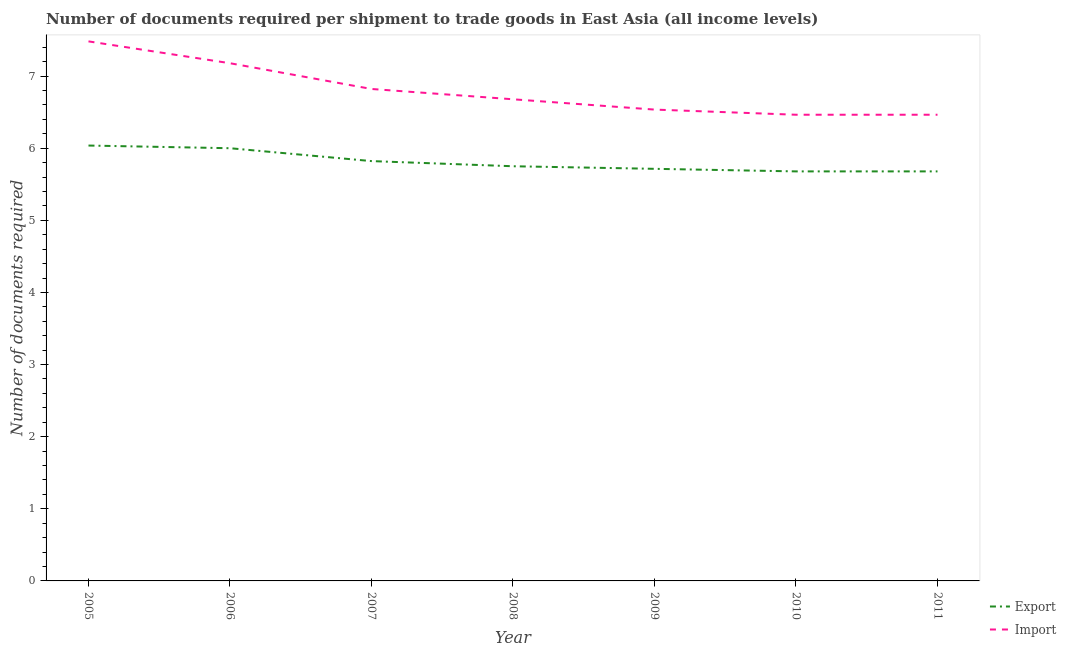How many different coloured lines are there?
Offer a terse response. 2. Does the line corresponding to number of documents required to import goods intersect with the line corresponding to number of documents required to export goods?
Offer a terse response. No. Is the number of lines equal to the number of legend labels?
Give a very brief answer. Yes. What is the number of documents required to export goods in 2011?
Ensure brevity in your answer.  5.68. Across all years, what is the maximum number of documents required to export goods?
Keep it short and to the point. 6.04. Across all years, what is the minimum number of documents required to export goods?
Your answer should be compact. 5.68. In which year was the number of documents required to import goods minimum?
Keep it short and to the point. 2010. What is the total number of documents required to export goods in the graph?
Offer a very short reply. 40.68. What is the difference between the number of documents required to import goods in 2009 and that in 2010?
Provide a short and direct response. 0.07. What is the difference between the number of documents required to import goods in 2010 and the number of documents required to export goods in 2009?
Offer a terse response. 0.75. What is the average number of documents required to import goods per year?
Give a very brief answer. 6.8. In the year 2007, what is the difference between the number of documents required to import goods and number of documents required to export goods?
Ensure brevity in your answer.  1. In how many years, is the number of documents required to export goods greater than 1?
Offer a very short reply. 7. What is the ratio of the number of documents required to import goods in 2007 to that in 2011?
Your answer should be very brief. 1.06. Is the number of documents required to export goods in 2005 less than that in 2011?
Ensure brevity in your answer.  No. Is the difference between the number of documents required to export goods in 2008 and 2010 greater than the difference between the number of documents required to import goods in 2008 and 2010?
Ensure brevity in your answer.  No. What is the difference between the highest and the second highest number of documents required to import goods?
Keep it short and to the point. 0.3. What is the difference between the highest and the lowest number of documents required to import goods?
Provide a short and direct response. 1.02. Is the sum of the number of documents required to import goods in 2006 and 2009 greater than the maximum number of documents required to export goods across all years?
Offer a terse response. Yes. Is the number of documents required to import goods strictly greater than the number of documents required to export goods over the years?
Your response must be concise. Yes. How many lines are there?
Your answer should be compact. 2. What is the difference between two consecutive major ticks on the Y-axis?
Your response must be concise. 1. Are the values on the major ticks of Y-axis written in scientific E-notation?
Your answer should be very brief. No. Does the graph contain any zero values?
Your answer should be compact. No. How many legend labels are there?
Offer a terse response. 2. How are the legend labels stacked?
Offer a terse response. Vertical. What is the title of the graph?
Offer a very short reply. Number of documents required per shipment to trade goods in East Asia (all income levels). Does "Constant 2005 US$" appear as one of the legend labels in the graph?
Provide a short and direct response. No. What is the label or title of the Y-axis?
Keep it short and to the point. Number of documents required. What is the Number of documents required of Export in 2005?
Keep it short and to the point. 6.04. What is the Number of documents required in Import in 2005?
Give a very brief answer. 7.48. What is the Number of documents required of Import in 2006?
Offer a terse response. 7.18. What is the Number of documents required in Export in 2007?
Your answer should be compact. 5.82. What is the Number of documents required of Import in 2007?
Keep it short and to the point. 6.82. What is the Number of documents required of Export in 2008?
Your answer should be compact. 5.75. What is the Number of documents required in Import in 2008?
Ensure brevity in your answer.  6.68. What is the Number of documents required of Export in 2009?
Your answer should be compact. 5.71. What is the Number of documents required of Import in 2009?
Your answer should be very brief. 6.54. What is the Number of documents required in Export in 2010?
Provide a short and direct response. 5.68. What is the Number of documents required in Import in 2010?
Your answer should be compact. 6.46. What is the Number of documents required in Export in 2011?
Your answer should be compact. 5.68. What is the Number of documents required of Import in 2011?
Offer a terse response. 6.46. Across all years, what is the maximum Number of documents required of Export?
Provide a succinct answer. 6.04. Across all years, what is the maximum Number of documents required in Import?
Offer a very short reply. 7.48. Across all years, what is the minimum Number of documents required of Export?
Your response must be concise. 5.68. Across all years, what is the minimum Number of documents required of Import?
Offer a terse response. 6.46. What is the total Number of documents required in Export in the graph?
Give a very brief answer. 40.68. What is the total Number of documents required in Import in the graph?
Ensure brevity in your answer.  47.62. What is the difference between the Number of documents required of Export in 2005 and that in 2006?
Ensure brevity in your answer.  0.04. What is the difference between the Number of documents required of Import in 2005 and that in 2006?
Provide a succinct answer. 0.3. What is the difference between the Number of documents required in Export in 2005 and that in 2007?
Give a very brief answer. 0.22. What is the difference between the Number of documents required in Import in 2005 and that in 2007?
Your answer should be compact. 0.66. What is the difference between the Number of documents required of Export in 2005 and that in 2008?
Offer a terse response. 0.29. What is the difference between the Number of documents required of Import in 2005 and that in 2008?
Your answer should be very brief. 0.8. What is the difference between the Number of documents required of Export in 2005 and that in 2009?
Provide a succinct answer. 0.32. What is the difference between the Number of documents required of Import in 2005 and that in 2009?
Offer a terse response. 0.95. What is the difference between the Number of documents required of Export in 2005 and that in 2010?
Provide a succinct answer. 0.36. What is the difference between the Number of documents required of Import in 2005 and that in 2010?
Offer a terse response. 1.02. What is the difference between the Number of documents required of Export in 2005 and that in 2011?
Keep it short and to the point. 0.36. What is the difference between the Number of documents required in Import in 2005 and that in 2011?
Your answer should be compact. 1.02. What is the difference between the Number of documents required in Export in 2006 and that in 2007?
Your answer should be very brief. 0.18. What is the difference between the Number of documents required of Import in 2006 and that in 2007?
Your answer should be very brief. 0.36. What is the difference between the Number of documents required in Export in 2006 and that in 2008?
Keep it short and to the point. 0.25. What is the difference between the Number of documents required in Import in 2006 and that in 2008?
Your answer should be compact. 0.5. What is the difference between the Number of documents required in Export in 2006 and that in 2009?
Provide a short and direct response. 0.29. What is the difference between the Number of documents required of Import in 2006 and that in 2009?
Offer a terse response. 0.64. What is the difference between the Number of documents required in Export in 2006 and that in 2010?
Offer a very short reply. 0.32. What is the difference between the Number of documents required of Export in 2006 and that in 2011?
Offer a very short reply. 0.32. What is the difference between the Number of documents required in Export in 2007 and that in 2008?
Your answer should be compact. 0.07. What is the difference between the Number of documents required of Import in 2007 and that in 2008?
Keep it short and to the point. 0.14. What is the difference between the Number of documents required of Export in 2007 and that in 2009?
Offer a terse response. 0.11. What is the difference between the Number of documents required in Import in 2007 and that in 2009?
Offer a terse response. 0.29. What is the difference between the Number of documents required in Export in 2007 and that in 2010?
Offer a very short reply. 0.14. What is the difference between the Number of documents required of Import in 2007 and that in 2010?
Give a very brief answer. 0.36. What is the difference between the Number of documents required of Export in 2007 and that in 2011?
Keep it short and to the point. 0.14. What is the difference between the Number of documents required of Import in 2007 and that in 2011?
Your answer should be very brief. 0.36. What is the difference between the Number of documents required of Export in 2008 and that in 2009?
Keep it short and to the point. 0.04. What is the difference between the Number of documents required in Import in 2008 and that in 2009?
Your answer should be very brief. 0.14. What is the difference between the Number of documents required of Export in 2008 and that in 2010?
Your answer should be very brief. 0.07. What is the difference between the Number of documents required of Import in 2008 and that in 2010?
Offer a terse response. 0.21. What is the difference between the Number of documents required in Export in 2008 and that in 2011?
Offer a very short reply. 0.07. What is the difference between the Number of documents required of Import in 2008 and that in 2011?
Ensure brevity in your answer.  0.21. What is the difference between the Number of documents required of Export in 2009 and that in 2010?
Offer a terse response. 0.04. What is the difference between the Number of documents required in Import in 2009 and that in 2010?
Your answer should be compact. 0.07. What is the difference between the Number of documents required in Export in 2009 and that in 2011?
Provide a succinct answer. 0.04. What is the difference between the Number of documents required in Import in 2009 and that in 2011?
Offer a very short reply. 0.07. What is the difference between the Number of documents required in Export in 2010 and that in 2011?
Provide a short and direct response. 0. What is the difference between the Number of documents required in Export in 2005 and the Number of documents required in Import in 2006?
Make the answer very short. -1.14. What is the difference between the Number of documents required of Export in 2005 and the Number of documents required of Import in 2007?
Offer a very short reply. -0.78. What is the difference between the Number of documents required in Export in 2005 and the Number of documents required in Import in 2008?
Provide a short and direct response. -0.64. What is the difference between the Number of documents required in Export in 2005 and the Number of documents required in Import in 2009?
Your response must be concise. -0.5. What is the difference between the Number of documents required in Export in 2005 and the Number of documents required in Import in 2010?
Your answer should be compact. -0.43. What is the difference between the Number of documents required in Export in 2005 and the Number of documents required in Import in 2011?
Your answer should be compact. -0.43. What is the difference between the Number of documents required in Export in 2006 and the Number of documents required in Import in 2007?
Make the answer very short. -0.82. What is the difference between the Number of documents required in Export in 2006 and the Number of documents required in Import in 2008?
Ensure brevity in your answer.  -0.68. What is the difference between the Number of documents required in Export in 2006 and the Number of documents required in Import in 2009?
Offer a very short reply. -0.54. What is the difference between the Number of documents required of Export in 2006 and the Number of documents required of Import in 2010?
Your answer should be very brief. -0.46. What is the difference between the Number of documents required of Export in 2006 and the Number of documents required of Import in 2011?
Give a very brief answer. -0.46. What is the difference between the Number of documents required in Export in 2007 and the Number of documents required in Import in 2008?
Give a very brief answer. -0.86. What is the difference between the Number of documents required of Export in 2007 and the Number of documents required of Import in 2009?
Offer a very short reply. -0.71. What is the difference between the Number of documents required of Export in 2007 and the Number of documents required of Import in 2010?
Ensure brevity in your answer.  -0.64. What is the difference between the Number of documents required of Export in 2007 and the Number of documents required of Import in 2011?
Ensure brevity in your answer.  -0.64. What is the difference between the Number of documents required of Export in 2008 and the Number of documents required of Import in 2009?
Provide a short and direct response. -0.79. What is the difference between the Number of documents required of Export in 2008 and the Number of documents required of Import in 2010?
Give a very brief answer. -0.71. What is the difference between the Number of documents required in Export in 2008 and the Number of documents required in Import in 2011?
Your answer should be compact. -0.71. What is the difference between the Number of documents required of Export in 2009 and the Number of documents required of Import in 2010?
Give a very brief answer. -0.75. What is the difference between the Number of documents required of Export in 2009 and the Number of documents required of Import in 2011?
Provide a short and direct response. -0.75. What is the difference between the Number of documents required in Export in 2010 and the Number of documents required in Import in 2011?
Offer a very short reply. -0.79. What is the average Number of documents required in Export per year?
Keep it short and to the point. 5.81. What is the average Number of documents required in Import per year?
Ensure brevity in your answer.  6.8. In the year 2005, what is the difference between the Number of documents required in Export and Number of documents required in Import?
Your answer should be compact. -1.44. In the year 2006, what is the difference between the Number of documents required of Export and Number of documents required of Import?
Keep it short and to the point. -1.18. In the year 2008, what is the difference between the Number of documents required of Export and Number of documents required of Import?
Make the answer very short. -0.93. In the year 2009, what is the difference between the Number of documents required in Export and Number of documents required in Import?
Give a very brief answer. -0.82. In the year 2010, what is the difference between the Number of documents required in Export and Number of documents required in Import?
Provide a succinct answer. -0.79. In the year 2011, what is the difference between the Number of documents required of Export and Number of documents required of Import?
Offer a terse response. -0.79. What is the ratio of the Number of documents required in Export in 2005 to that in 2006?
Provide a short and direct response. 1.01. What is the ratio of the Number of documents required of Import in 2005 to that in 2006?
Offer a very short reply. 1.04. What is the ratio of the Number of documents required in Import in 2005 to that in 2007?
Make the answer very short. 1.1. What is the ratio of the Number of documents required of Export in 2005 to that in 2008?
Make the answer very short. 1.05. What is the ratio of the Number of documents required in Import in 2005 to that in 2008?
Give a very brief answer. 1.12. What is the ratio of the Number of documents required in Export in 2005 to that in 2009?
Offer a very short reply. 1.06. What is the ratio of the Number of documents required of Import in 2005 to that in 2009?
Keep it short and to the point. 1.14. What is the ratio of the Number of documents required in Export in 2005 to that in 2010?
Offer a terse response. 1.06. What is the ratio of the Number of documents required in Import in 2005 to that in 2010?
Keep it short and to the point. 1.16. What is the ratio of the Number of documents required in Export in 2005 to that in 2011?
Provide a short and direct response. 1.06. What is the ratio of the Number of documents required of Import in 2005 to that in 2011?
Make the answer very short. 1.16. What is the ratio of the Number of documents required in Export in 2006 to that in 2007?
Provide a short and direct response. 1.03. What is the ratio of the Number of documents required in Import in 2006 to that in 2007?
Your answer should be very brief. 1.05. What is the ratio of the Number of documents required in Export in 2006 to that in 2008?
Provide a succinct answer. 1.04. What is the ratio of the Number of documents required of Import in 2006 to that in 2008?
Your response must be concise. 1.07. What is the ratio of the Number of documents required of Import in 2006 to that in 2009?
Your response must be concise. 1.1. What is the ratio of the Number of documents required in Export in 2006 to that in 2010?
Your answer should be very brief. 1.06. What is the ratio of the Number of documents required in Import in 2006 to that in 2010?
Your answer should be compact. 1.11. What is the ratio of the Number of documents required of Export in 2006 to that in 2011?
Your answer should be very brief. 1.06. What is the ratio of the Number of documents required of Import in 2006 to that in 2011?
Offer a very short reply. 1.11. What is the ratio of the Number of documents required of Export in 2007 to that in 2008?
Make the answer very short. 1.01. What is the ratio of the Number of documents required in Import in 2007 to that in 2008?
Offer a very short reply. 1.02. What is the ratio of the Number of documents required of Export in 2007 to that in 2009?
Your answer should be very brief. 1.02. What is the ratio of the Number of documents required of Import in 2007 to that in 2009?
Give a very brief answer. 1.04. What is the ratio of the Number of documents required of Export in 2007 to that in 2010?
Ensure brevity in your answer.  1.03. What is the ratio of the Number of documents required in Import in 2007 to that in 2010?
Offer a terse response. 1.06. What is the ratio of the Number of documents required of Export in 2007 to that in 2011?
Offer a very short reply. 1.03. What is the ratio of the Number of documents required in Import in 2007 to that in 2011?
Your answer should be compact. 1.06. What is the ratio of the Number of documents required of Import in 2008 to that in 2009?
Ensure brevity in your answer.  1.02. What is the ratio of the Number of documents required in Export in 2008 to that in 2010?
Make the answer very short. 1.01. What is the ratio of the Number of documents required of Import in 2008 to that in 2010?
Make the answer very short. 1.03. What is the ratio of the Number of documents required of Export in 2008 to that in 2011?
Your answer should be compact. 1.01. What is the ratio of the Number of documents required of Import in 2008 to that in 2011?
Provide a short and direct response. 1.03. What is the difference between the highest and the second highest Number of documents required in Export?
Your answer should be very brief. 0.04. What is the difference between the highest and the second highest Number of documents required of Import?
Give a very brief answer. 0.3. What is the difference between the highest and the lowest Number of documents required in Export?
Your response must be concise. 0.36. What is the difference between the highest and the lowest Number of documents required of Import?
Keep it short and to the point. 1.02. 